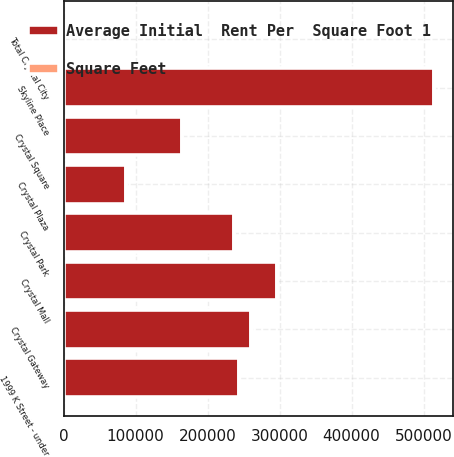Convert chart. <chart><loc_0><loc_0><loc_500><loc_500><stacked_bar_chart><ecel><fcel>Crystal Mall<fcel>Crystal Gateway<fcel>Crystal Park<fcel>Crystal Square<fcel>Crystal Plaza<fcel>Total Crystal City<fcel>Skyline Place<fcel>1999 K Street - under<nl><fcel>Average Initial  Rent Per  Square Foot 1<fcel>296000<fcel>261000<fcel>237000<fcel>164000<fcel>87000<fcel>76.5<fcel>515000<fcel>243000<nl><fcel>Square Feet<fcel>31.87<fcel>35.6<fcel>35.58<fcel>35.12<fcel>30.32<fcel>34.02<fcel>30.16<fcel>76.5<nl></chart> 